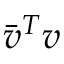Convert formula to latex. <formula><loc_0><loc_0><loc_500><loc_500>{ \bar { v } } ^ { T } v</formula> 